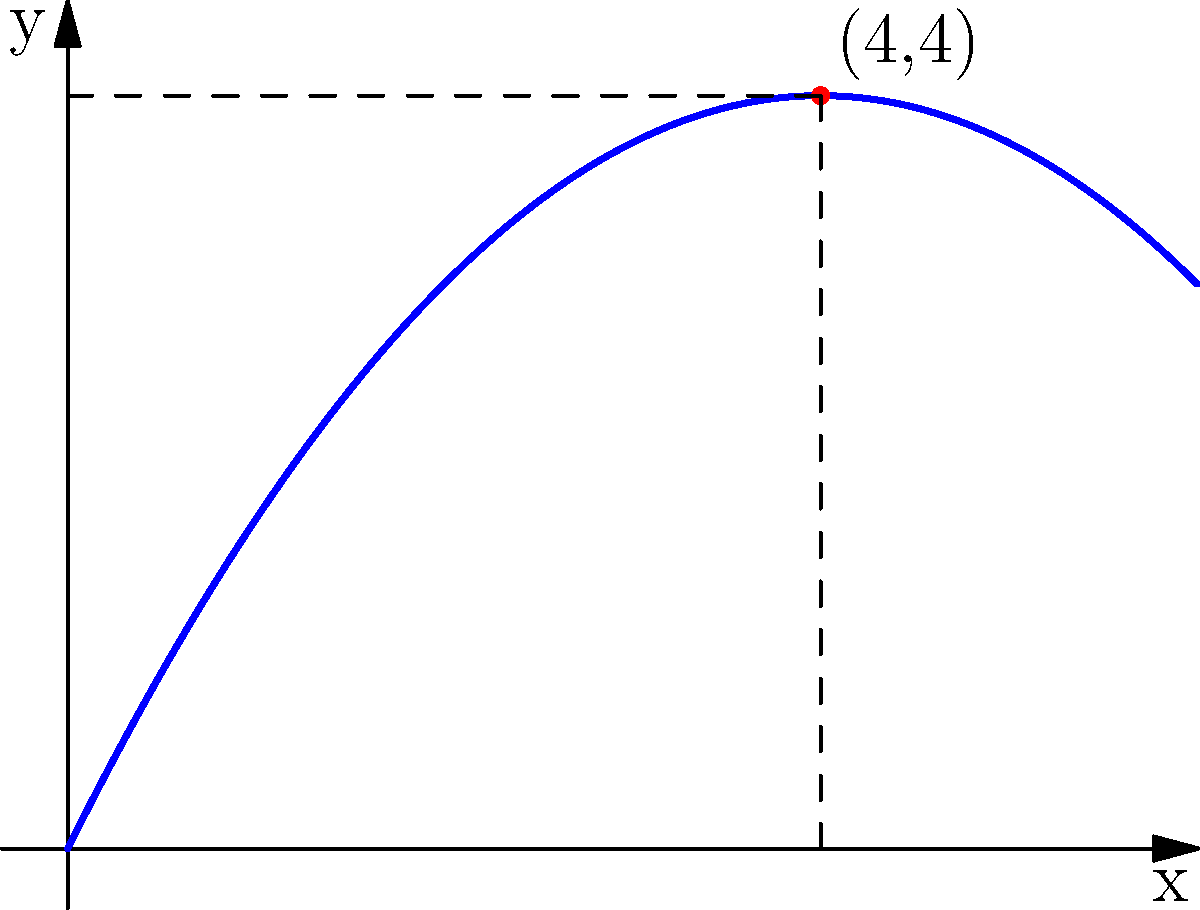In a recent issue of "Captain America," the hero throws his iconic shield, which follows a parabolic path. The trajectory of the shield can be modeled by the function $f(x) = -0.25x^2 + 2x$, where $x$ represents the horizontal distance and $f(x)$ the vertical height, both measured in meters. At what horizontal distance does Captain America's shield reach its maximum height? To find the maximum height of the parabolic trajectory, we need to follow these steps:

1) The parabola reaches its maximum height at the vertex of the parabola.

2) For a quadratic function in the form $f(x) = ax^2 + bx + c$, the x-coordinate of the vertex is given by $x = -\frac{b}{2a}$.

3) In our case, $f(x) = -0.25x^2 + 2x$, so $a = -0.25$ and $b = 2$.

4) Plugging these values into the formula:

   $x = -\frac{2}{2(-0.25)} = -\frac{2}{-0.5} = 4$

5) Therefore, the shield reaches its maximum height when $x = 4$ meters.

6) We can verify this by looking at the graph, where we see the vertex at (4,4).

This aligns with the physics of projectile motion, where an object reaches its peak height halfway through its flight path.
Answer: 4 meters 